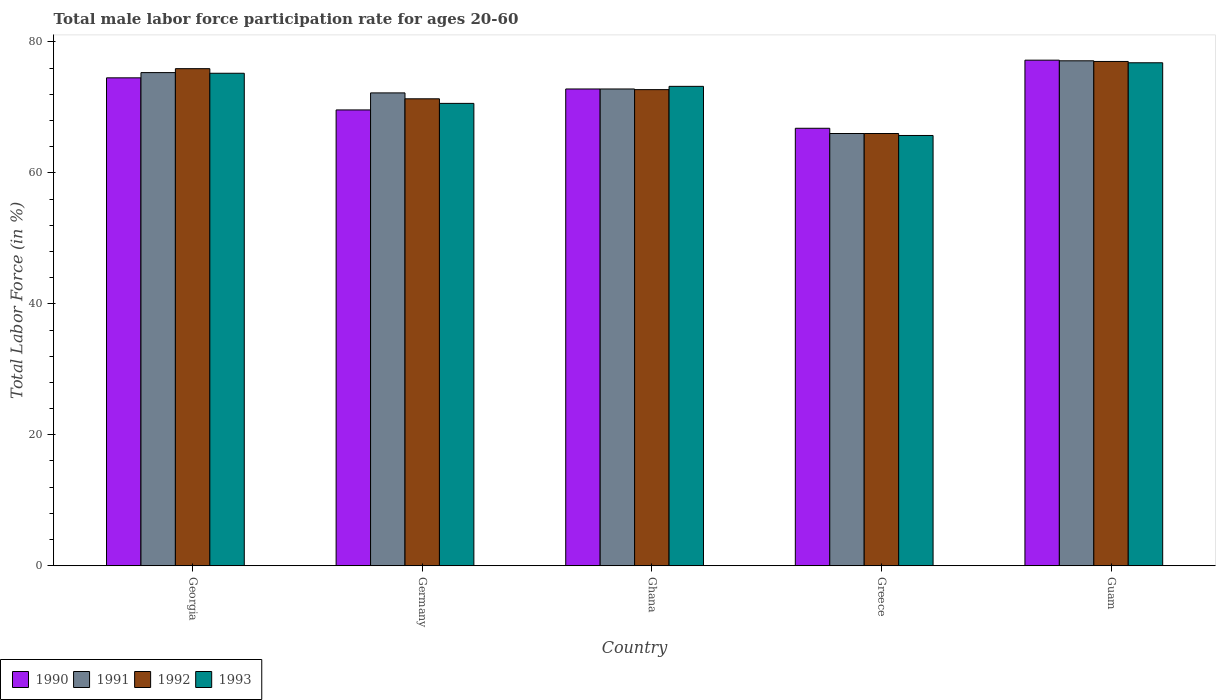How many groups of bars are there?
Make the answer very short. 5. Are the number of bars on each tick of the X-axis equal?
Offer a very short reply. Yes. What is the label of the 3rd group of bars from the left?
Provide a succinct answer. Ghana. What is the male labor force participation rate in 1993 in Germany?
Keep it short and to the point. 70.6. Across all countries, what is the maximum male labor force participation rate in 1991?
Provide a succinct answer. 77.1. Across all countries, what is the minimum male labor force participation rate in 1992?
Ensure brevity in your answer.  66. In which country was the male labor force participation rate in 1993 maximum?
Your answer should be compact. Guam. What is the total male labor force participation rate in 1990 in the graph?
Provide a short and direct response. 360.9. What is the difference between the male labor force participation rate in 1990 in Germany and that in Greece?
Offer a terse response. 2.8. What is the difference between the male labor force participation rate in 1990 in Greece and the male labor force participation rate in 1991 in Ghana?
Your response must be concise. -6. What is the average male labor force participation rate in 1992 per country?
Your answer should be very brief. 72.58. What is the difference between the male labor force participation rate of/in 1990 and male labor force participation rate of/in 1992 in Guam?
Provide a succinct answer. 0.2. In how many countries, is the male labor force participation rate in 1991 greater than 16 %?
Ensure brevity in your answer.  5. What is the ratio of the male labor force participation rate in 1992 in Georgia to that in Ghana?
Provide a succinct answer. 1.04. Is the difference between the male labor force participation rate in 1990 in Greece and Guam greater than the difference between the male labor force participation rate in 1992 in Greece and Guam?
Offer a terse response. Yes. What is the difference between the highest and the lowest male labor force participation rate in 1991?
Provide a succinct answer. 11.1. Is the sum of the male labor force participation rate in 1992 in Ghana and Greece greater than the maximum male labor force participation rate in 1990 across all countries?
Keep it short and to the point. Yes. Is it the case that in every country, the sum of the male labor force participation rate in 1992 and male labor force participation rate in 1990 is greater than the sum of male labor force participation rate in 1991 and male labor force participation rate in 1993?
Make the answer very short. No. What does the 2nd bar from the left in Greece represents?
Make the answer very short. 1991. How many bars are there?
Offer a terse response. 20. Does the graph contain any zero values?
Offer a terse response. No. Does the graph contain grids?
Your answer should be compact. No. Where does the legend appear in the graph?
Provide a short and direct response. Bottom left. How are the legend labels stacked?
Offer a very short reply. Horizontal. What is the title of the graph?
Your answer should be compact. Total male labor force participation rate for ages 20-60. What is the label or title of the Y-axis?
Offer a very short reply. Total Labor Force (in %). What is the Total Labor Force (in %) in 1990 in Georgia?
Offer a terse response. 74.5. What is the Total Labor Force (in %) in 1991 in Georgia?
Provide a succinct answer. 75.3. What is the Total Labor Force (in %) of 1992 in Georgia?
Ensure brevity in your answer.  75.9. What is the Total Labor Force (in %) of 1993 in Georgia?
Provide a succinct answer. 75.2. What is the Total Labor Force (in %) of 1990 in Germany?
Keep it short and to the point. 69.6. What is the Total Labor Force (in %) in 1991 in Germany?
Offer a terse response. 72.2. What is the Total Labor Force (in %) in 1992 in Germany?
Your response must be concise. 71.3. What is the Total Labor Force (in %) in 1993 in Germany?
Offer a terse response. 70.6. What is the Total Labor Force (in %) of 1990 in Ghana?
Offer a terse response. 72.8. What is the Total Labor Force (in %) of 1991 in Ghana?
Your answer should be compact. 72.8. What is the Total Labor Force (in %) in 1992 in Ghana?
Offer a terse response. 72.7. What is the Total Labor Force (in %) in 1993 in Ghana?
Provide a short and direct response. 73.2. What is the Total Labor Force (in %) of 1990 in Greece?
Give a very brief answer. 66.8. What is the Total Labor Force (in %) in 1992 in Greece?
Provide a succinct answer. 66. What is the Total Labor Force (in %) in 1993 in Greece?
Keep it short and to the point. 65.7. What is the Total Labor Force (in %) of 1990 in Guam?
Your response must be concise. 77.2. What is the Total Labor Force (in %) of 1991 in Guam?
Offer a very short reply. 77.1. What is the Total Labor Force (in %) in 1992 in Guam?
Your answer should be very brief. 77. What is the Total Labor Force (in %) in 1993 in Guam?
Your answer should be compact. 76.8. Across all countries, what is the maximum Total Labor Force (in %) of 1990?
Give a very brief answer. 77.2. Across all countries, what is the maximum Total Labor Force (in %) in 1991?
Your answer should be compact. 77.1. Across all countries, what is the maximum Total Labor Force (in %) of 1992?
Make the answer very short. 77. Across all countries, what is the maximum Total Labor Force (in %) in 1993?
Provide a short and direct response. 76.8. Across all countries, what is the minimum Total Labor Force (in %) of 1990?
Give a very brief answer. 66.8. Across all countries, what is the minimum Total Labor Force (in %) in 1993?
Make the answer very short. 65.7. What is the total Total Labor Force (in %) in 1990 in the graph?
Offer a terse response. 360.9. What is the total Total Labor Force (in %) in 1991 in the graph?
Offer a terse response. 363.4. What is the total Total Labor Force (in %) of 1992 in the graph?
Provide a short and direct response. 362.9. What is the total Total Labor Force (in %) of 1993 in the graph?
Offer a very short reply. 361.5. What is the difference between the Total Labor Force (in %) in 1992 in Georgia and that in Germany?
Offer a very short reply. 4.6. What is the difference between the Total Labor Force (in %) in 1993 in Georgia and that in Germany?
Offer a terse response. 4.6. What is the difference between the Total Labor Force (in %) of 1990 in Georgia and that in Ghana?
Make the answer very short. 1.7. What is the difference between the Total Labor Force (in %) in 1992 in Georgia and that in Greece?
Offer a terse response. 9.9. What is the difference between the Total Labor Force (in %) in 1990 in Georgia and that in Guam?
Give a very brief answer. -2.7. What is the difference between the Total Labor Force (in %) in 1993 in Georgia and that in Guam?
Keep it short and to the point. -1.6. What is the difference between the Total Labor Force (in %) in 1991 in Germany and that in Ghana?
Keep it short and to the point. -0.6. What is the difference between the Total Labor Force (in %) of 1992 in Germany and that in Ghana?
Offer a very short reply. -1.4. What is the difference between the Total Labor Force (in %) in 1993 in Germany and that in Ghana?
Your answer should be compact. -2.6. What is the difference between the Total Labor Force (in %) in 1990 in Germany and that in Greece?
Give a very brief answer. 2.8. What is the difference between the Total Labor Force (in %) in 1991 in Germany and that in Guam?
Provide a succinct answer. -4.9. What is the difference between the Total Labor Force (in %) in 1992 in Ghana and that in Greece?
Your response must be concise. 6.7. What is the difference between the Total Labor Force (in %) of 1993 in Ghana and that in Greece?
Make the answer very short. 7.5. What is the difference between the Total Labor Force (in %) in 1990 in Ghana and that in Guam?
Your response must be concise. -4.4. What is the difference between the Total Labor Force (in %) of 1992 in Ghana and that in Guam?
Provide a succinct answer. -4.3. What is the difference between the Total Labor Force (in %) in 1993 in Ghana and that in Guam?
Your response must be concise. -3.6. What is the difference between the Total Labor Force (in %) in 1990 in Georgia and the Total Labor Force (in %) in 1992 in Germany?
Offer a very short reply. 3.2. What is the difference between the Total Labor Force (in %) in 1990 in Georgia and the Total Labor Force (in %) in 1993 in Germany?
Ensure brevity in your answer.  3.9. What is the difference between the Total Labor Force (in %) in 1991 in Georgia and the Total Labor Force (in %) in 1992 in Germany?
Your response must be concise. 4. What is the difference between the Total Labor Force (in %) of 1990 in Georgia and the Total Labor Force (in %) of 1992 in Ghana?
Provide a short and direct response. 1.8. What is the difference between the Total Labor Force (in %) of 1990 in Georgia and the Total Labor Force (in %) of 1993 in Ghana?
Your response must be concise. 1.3. What is the difference between the Total Labor Force (in %) of 1991 in Georgia and the Total Labor Force (in %) of 1993 in Ghana?
Provide a succinct answer. 2.1. What is the difference between the Total Labor Force (in %) of 1990 in Georgia and the Total Labor Force (in %) of 1991 in Greece?
Ensure brevity in your answer.  8.5. What is the difference between the Total Labor Force (in %) of 1991 in Georgia and the Total Labor Force (in %) of 1992 in Greece?
Your answer should be compact. 9.3. What is the difference between the Total Labor Force (in %) in 1991 in Georgia and the Total Labor Force (in %) in 1993 in Greece?
Give a very brief answer. 9.6. What is the difference between the Total Labor Force (in %) of 1990 in Georgia and the Total Labor Force (in %) of 1991 in Guam?
Provide a succinct answer. -2.6. What is the difference between the Total Labor Force (in %) in 1991 in Georgia and the Total Labor Force (in %) in 1992 in Guam?
Offer a very short reply. -1.7. What is the difference between the Total Labor Force (in %) in 1990 in Germany and the Total Labor Force (in %) in 1991 in Ghana?
Offer a terse response. -3.2. What is the difference between the Total Labor Force (in %) of 1990 in Germany and the Total Labor Force (in %) of 1991 in Greece?
Your answer should be compact. 3.6. What is the difference between the Total Labor Force (in %) of 1990 in Germany and the Total Labor Force (in %) of 1993 in Greece?
Give a very brief answer. 3.9. What is the difference between the Total Labor Force (in %) in 1991 in Germany and the Total Labor Force (in %) in 1992 in Greece?
Offer a terse response. 6.2. What is the difference between the Total Labor Force (in %) in 1992 in Germany and the Total Labor Force (in %) in 1993 in Greece?
Keep it short and to the point. 5.6. What is the difference between the Total Labor Force (in %) in 1990 in Germany and the Total Labor Force (in %) in 1992 in Guam?
Your answer should be compact. -7.4. What is the difference between the Total Labor Force (in %) of 1990 in Germany and the Total Labor Force (in %) of 1993 in Guam?
Keep it short and to the point. -7.2. What is the difference between the Total Labor Force (in %) of 1991 in Germany and the Total Labor Force (in %) of 1993 in Guam?
Provide a short and direct response. -4.6. What is the difference between the Total Labor Force (in %) in 1992 in Germany and the Total Labor Force (in %) in 1993 in Guam?
Your answer should be compact. -5.5. What is the difference between the Total Labor Force (in %) in 1990 in Ghana and the Total Labor Force (in %) in 1991 in Greece?
Ensure brevity in your answer.  6.8. What is the difference between the Total Labor Force (in %) in 1991 in Ghana and the Total Labor Force (in %) in 1993 in Greece?
Your answer should be very brief. 7.1. What is the difference between the Total Labor Force (in %) of 1992 in Ghana and the Total Labor Force (in %) of 1993 in Greece?
Your answer should be compact. 7. What is the difference between the Total Labor Force (in %) of 1990 in Ghana and the Total Labor Force (in %) of 1993 in Guam?
Make the answer very short. -4. What is the difference between the Total Labor Force (in %) of 1990 in Greece and the Total Labor Force (in %) of 1993 in Guam?
Offer a terse response. -10. What is the average Total Labor Force (in %) in 1990 per country?
Ensure brevity in your answer.  72.18. What is the average Total Labor Force (in %) of 1991 per country?
Make the answer very short. 72.68. What is the average Total Labor Force (in %) of 1992 per country?
Keep it short and to the point. 72.58. What is the average Total Labor Force (in %) of 1993 per country?
Give a very brief answer. 72.3. What is the difference between the Total Labor Force (in %) in 1990 and Total Labor Force (in %) in 1991 in Georgia?
Keep it short and to the point. -0.8. What is the difference between the Total Labor Force (in %) in 1990 and Total Labor Force (in %) in 1992 in Georgia?
Your answer should be very brief. -1.4. What is the difference between the Total Labor Force (in %) in 1990 and Total Labor Force (in %) in 1993 in Georgia?
Make the answer very short. -0.7. What is the difference between the Total Labor Force (in %) of 1991 and Total Labor Force (in %) of 1992 in Georgia?
Give a very brief answer. -0.6. What is the difference between the Total Labor Force (in %) of 1990 and Total Labor Force (in %) of 1992 in Germany?
Provide a short and direct response. -1.7. What is the difference between the Total Labor Force (in %) of 1990 and Total Labor Force (in %) of 1993 in Germany?
Ensure brevity in your answer.  -1. What is the difference between the Total Labor Force (in %) of 1991 and Total Labor Force (in %) of 1992 in Germany?
Your response must be concise. 0.9. What is the difference between the Total Labor Force (in %) in 1992 and Total Labor Force (in %) in 1993 in Germany?
Your answer should be compact. 0.7. What is the difference between the Total Labor Force (in %) of 1990 and Total Labor Force (in %) of 1992 in Ghana?
Provide a succinct answer. 0.1. What is the difference between the Total Labor Force (in %) of 1990 and Total Labor Force (in %) of 1993 in Ghana?
Your response must be concise. -0.4. What is the difference between the Total Labor Force (in %) of 1990 and Total Labor Force (in %) of 1991 in Greece?
Provide a succinct answer. 0.8. What is the difference between the Total Labor Force (in %) of 1990 and Total Labor Force (in %) of 1993 in Greece?
Provide a succinct answer. 1.1. What is the difference between the Total Labor Force (in %) of 1991 and Total Labor Force (in %) of 1992 in Greece?
Provide a succinct answer. 0. What is the difference between the Total Labor Force (in %) in 1992 and Total Labor Force (in %) in 1993 in Greece?
Give a very brief answer. 0.3. What is the difference between the Total Labor Force (in %) in 1990 and Total Labor Force (in %) in 1991 in Guam?
Your response must be concise. 0.1. What is the difference between the Total Labor Force (in %) in 1990 and Total Labor Force (in %) in 1992 in Guam?
Your answer should be very brief. 0.2. What is the difference between the Total Labor Force (in %) of 1990 and Total Labor Force (in %) of 1993 in Guam?
Your response must be concise. 0.4. What is the difference between the Total Labor Force (in %) of 1991 and Total Labor Force (in %) of 1993 in Guam?
Offer a very short reply. 0.3. What is the ratio of the Total Labor Force (in %) in 1990 in Georgia to that in Germany?
Make the answer very short. 1.07. What is the ratio of the Total Labor Force (in %) of 1991 in Georgia to that in Germany?
Provide a short and direct response. 1.04. What is the ratio of the Total Labor Force (in %) in 1992 in Georgia to that in Germany?
Your response must be concise. 1.06. What is the ratio of the Total Labor Force (in %) of 1993 in Georgia to that in Germany?
Make the answer very short. 1.07. What is the ratio of the Total Labor Force (in %) in 1990 in Georgia to that in Ghana?
Offer a very short reply. 1.02. What is the ratio of the Total Labor Force (in %) in 1991 in Georgia to that in Ghana?
Your answer should be compact. 1.03. What is the ratio of the Total Labor Force (in %) of 1992 in Georgia to that in Ghana?
Provide a succinct answer. 1.04. What is the ratio of the Total Labor Force (in %) of 1993 in Georgia to that in Ghana?
Provide a short and direct response. 1.03. What is the ratio of the Total Labor Force (in %) in 1990 in Georgia to that in Greece?
Give a very brief answer. 1.12. What is the ratio of the Total Labor Force (in %) of 1991 in Georgia to that in Greece?
Offer a terse response. 1.14. What is the ratio of the Total Labor Force (in %) in 1992 in Georgia to that in Greece?
Provide a succinct answer. 1.15. What is the ratio of the Total Labor Force (in %) of 1993 in Georgia to that in Greece?
Provide a succinct answer. 1.14. What is the ratio of the Total Labor Force (in %) of 1990 in Georgia to that in Guam?
Your answer should be very brief. 0.96. What is the ratio of the Total Labor Force (in %) in 1991 in Georgia to that in Guam?
Offer a very short reply. 0.98. What is the ratio of the Total Labor Force (in %) of 1992 in Georgia to that in Guam?
Offer a very short reply. 0.99. What is the ratio of the Total Labor Force (in %) in 1993 in Georgia to that in Guam?
Provide a succinct answer. 0.98. What is the ratio of the Total Labor Force (in %) in 1990 in Germany to that in Ghana?
Ensure brevity in your answer.  0.96. What is the ratio of the Total Labor Force (in %) of 1992 in Germany to that in Ghana?
Offer a terse response. 0.98. What is the ratio of the Total Labor Force (in %) in 1993 in Germany to that in Ghana?
Provide a succinct answer. 0.96. What is the ratio of the Total Labor Force (in %) in 1990 in Germany to that in Greece?
Ensure brevity in your answer.  1.04. What is the ratio of the Total Labor Force (in %) in 1991 in Germany to that in Greece?
Your response must be concise. 1.09. What is the ratio of the Total Labor Force (in %) in 1992 in Germany to that in Greece?
Offer a terse response. 1.08. What is the ratio of the Total Labor Force (in %) in 1993 in Germany to that in Greece?
Keep it short and to the point. 1.07. What is the ratio of the Total Labor Force (in %) in 1990 in Germany to that in Guam?
Provide a short and direct response. 0.9. What is the ratio of the Total Labor Force (in %) of 1991 in Germany to that in Guam?
Your answer should be compact. 0.94. What is the ratio of the Total Labor Force (in %) of 1992 in Germany to that in Guam?
Provide a succinct answer. 0.93. What is the ratio of the Total Labor Force (in %) of 1993 in Germany to that in Guam?
Your response must be concise. 0.92. What is the ratio of the Total Labor Force (in %) in 1990 in Ghana to that in Greece?
Provide a short and direct response. 1.09. What is the ratio of the Total Labor Force (in %) in 1991 in Ghana to that in Greece?
Your response must be concise. 1.1. What is the ratio of the Total Labor Force (in %) in 1992 in Ghana to that in Greece?
Your response must be concise. 1.1. What is the ratio of the Total Labor Force (in %) in 1993 in Ghana to that in Greece?
Your answer should be compact. 1.11. What is the ratio of the Total Labor Force (in %) in 1990 in Ghana to that in Guam?
Your answer should be compact. 0.94. What is the ratio of the Total Labor Force (in %) in 1991 in Ghana to that in Guam?
Offer a very short reply. 0.94. What is the ratio of the Total Labor Force (in %) of 1992 in Ghana to that in Guam?
Provide a short and direct response. 0.94. What is the ratio of the Total Labor Force (in %) of 1993 in Ghana to that in Guam?
Offer a terse response. 0.95. What is the ratio of the Total Labor Force (in %) of 1990 in Greece to that in Guam?
Offer a terse response. 0.87. What is the ratio of the Total Labor Force (in %) of 1991 in Greece to that in Guam?
Offer a very short reply. 0.86. What is the ratio of the Total Labor Force (in %) in 1993 in Greece to that in Guam?
Provide a succinct answer. 0.86. What is the difference between the highest and the second highest Total Labor Force (in %) in 1991?
Your answer should be compact. 1.8. What is the difference between the highest and the second highest Total Labor Force (in %) of 1992?
Give a very brief answer. 1.1. What is the difference between the highest and the second highest Total Labor Force (in %) of 1993?
Provide a succinct answer. 1.6. What is the difference between the highest and the lowest Total Labor Force (in %) of 1991?
Your answer should be very brief. 11.1. What is the difference between the highest and the lowest Total Labor Force (in %) in 1992?
Keep it short and to the point. 11. What is the difference between the highest and the lowest Total Labor Force (in %) in 1993?
Provide a succinct answer. 11.1. 